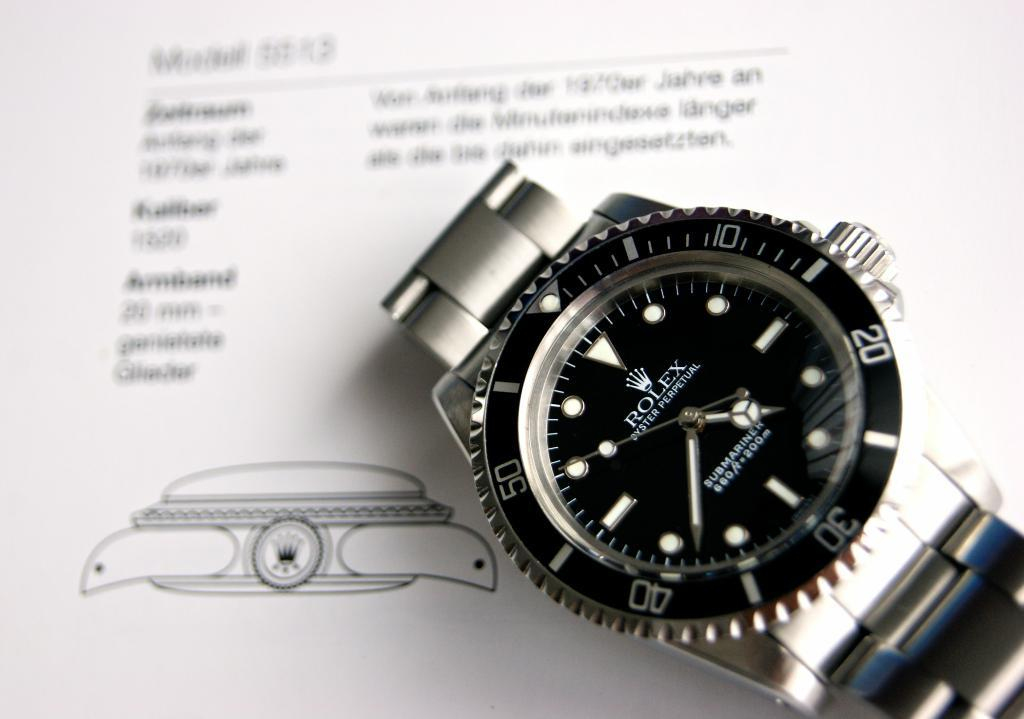<image>
Present a compact description of the photo's key features. The Rolex Submariner watch is displayed on a paper of watch information. 